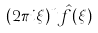Convert formula to latex. <formula><loc_0><loc_0><loc_500><loc_500>( 2 \pi i \xi ) ^ { n } { \hat { f } } ( \xi )</formula> 